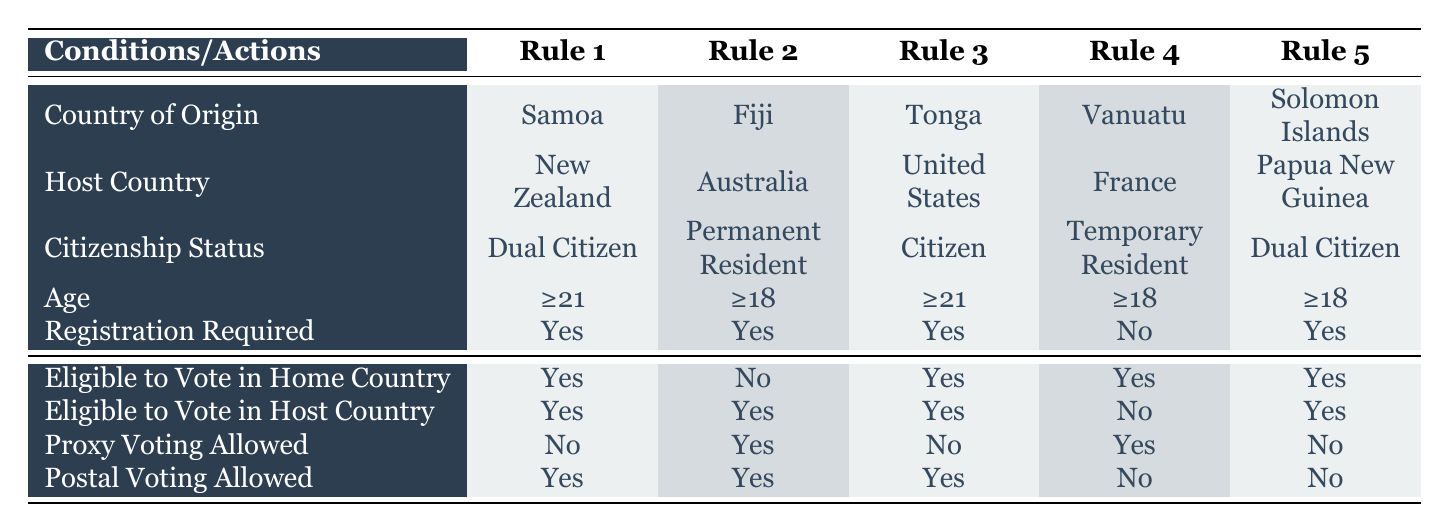What are the voting eligibility criteria for a dual citizen from Samoa living in New Zealand? According to Rule 1, the dual citizen from Samoa who resides in New Zealand must be aged 21 or older, is required to register to vote, and is eligible to vote in both their home country and host country. They are not allowed to vote by proxy but can vote by post.
Answer: Age ≥21, Registration Required: Yes, Eligible to Vote in Home Country: Yes, Eligible to Vote in Host Country: Yes, Proxy Voting Allowed: No, Postal Voting Allowed: Yes Is a permanent resident from Fiji eligible to vote in the home country? Referring to Rule 2, a permanent resident from Fiji is not eligible to vote in their home country. The table specifies that eligibility for voting in their home country is marked as "No."
Answer: No How many Pacific Islander nations in the table allow postal voting? By analyzing each row, postal voting is allowed for Samoa, Fiji, Tonga (3 nations total). However, Vanuatu and Solomon Islands do not allow postal voting, resulting in a total count.
Answer: 3 Can a temporary resident from Vanuatu vote in the host country? According to Rule 4, a temporary resident from Vanuatu is not eligible to vote in the host country (France), as indicated by "No" in the table for that particular category.
Answer: No If a dual citizen from the Solomon Islands is living in Papua New Guinea, what voting options are available? Rule 5 shows that a dual citizen from the Solomon Islands in Papua New Guinea can vote in both their home country and the host country. However, proxy voting is not allowed, and postal voting is also not allowed.
Answer: Home Country: Yes, Host Country: Yes, Proxy Voting: No, Postal Voting: No For those who are under 21, which Pacific Islander nationality would they belong to based on the table? Based on the information provided, only the permanent resident from Fiji and temporary resident from Vanuatu (Rule 2 and Rule 4) allow voting at age 18 or older. Therefore, nationality includes Fiji and Vanuatu.
Answer: Fiji, Vanuatu What is the citizenship status of someone who can vote in both their home and host country? Analyzing the table, dual citizens from Samoa and Solomon Islands and citizens from Tonga are eligible to vote in both their home and host countries. Therefore, the citizenship status for each is dual citizen or citizen.
Answer: Dual Citizen (Samoa, Solomon Islands), Citizen (Tonga) Is proxy voting allowed for citizens living in the United States? Rule 3 indicates that proxy voting is not allowed for citizens from Tonga living in the U.S. Therefore, the answer is "No" based on the information in the table.
Answer: No 